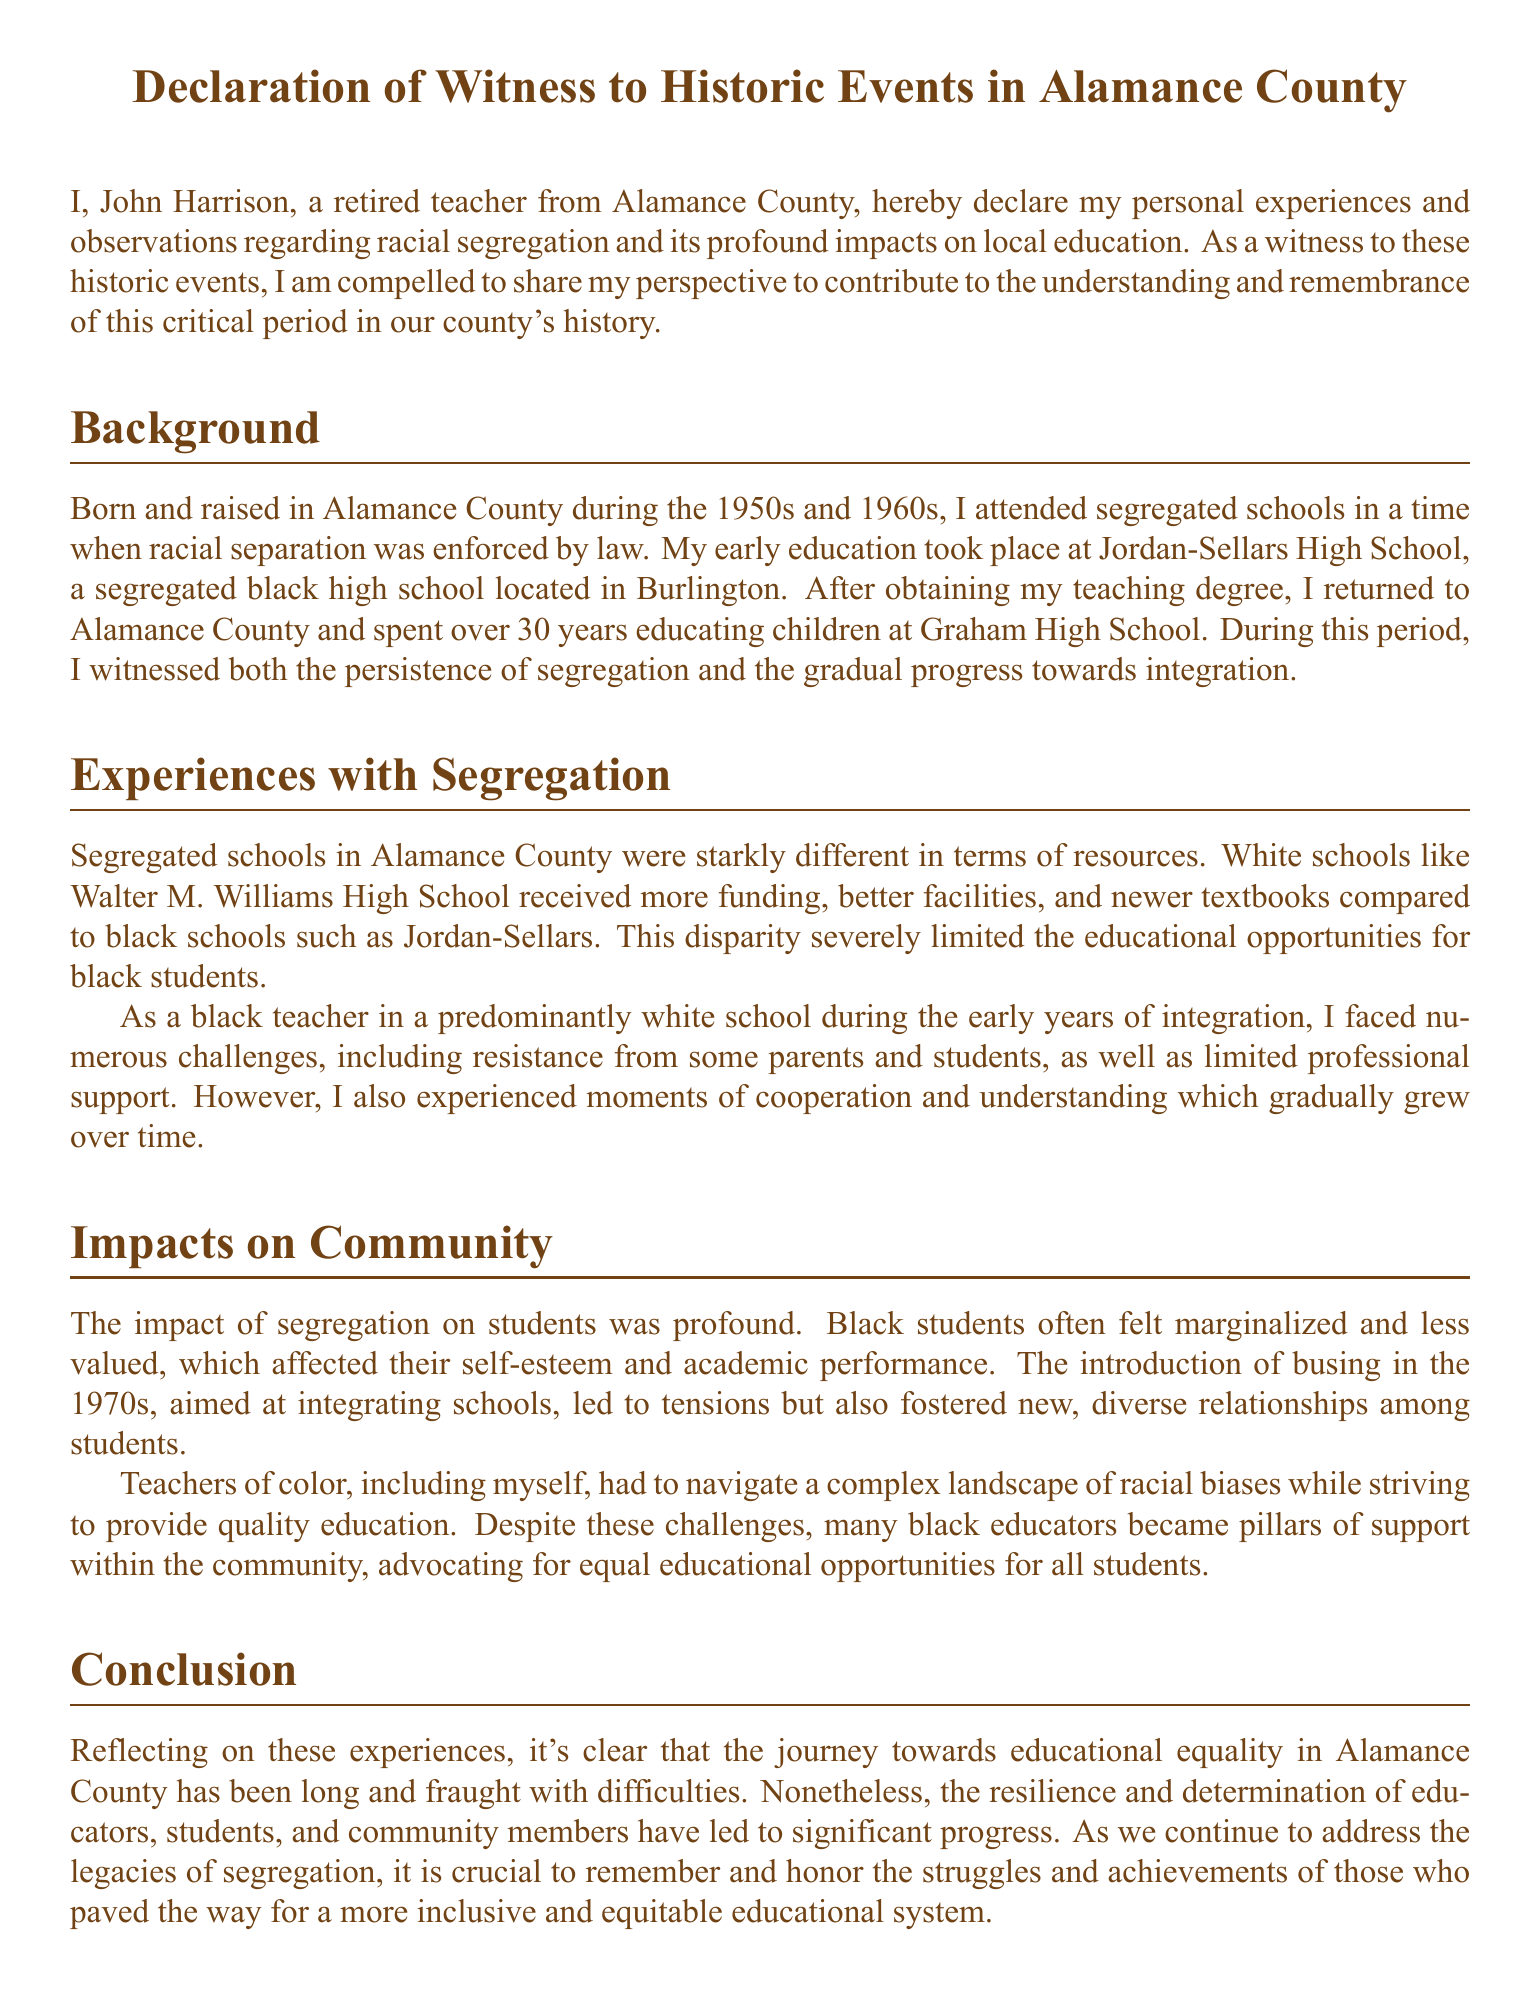What is the name of the author? The author of the document is introduced at the beginning, stating their name as John Harrison.
Answer: John Harrison What high school did the author attend? The document mentions that the author attended Jordan-Sellars High School, a segregated black high school.
Answer: Jordan-Sellars High School How long did the author teach in Alamance County? The author states that they spent over 30 years educating children at Graham High School in Alamance County.
Answer: over 30 years What year is the document signed? The final section of the document specifies the date it was signed as October 5, 2023.
Answer: October 5, 2023 What was the primary difference in funding between schools? The document highlights that white schools like Walter M. Williams High School received more funding compared to black schools.
Answer: more funding What was introduced in the 1970s for school integration? The document notes that busing was introduced in the 1970s to integrate schools.
Answer: busing What role did black educators play in the community? The author reflects that many black educators became pillars of support within the community, advocating for equality.
Answer: pillars of support What is the document primarily about? The document serves as a declaration of personal experiences regarding racial segregation and its impacts on education in Alamance County.
Answer: racial segregation and its impacts on education 